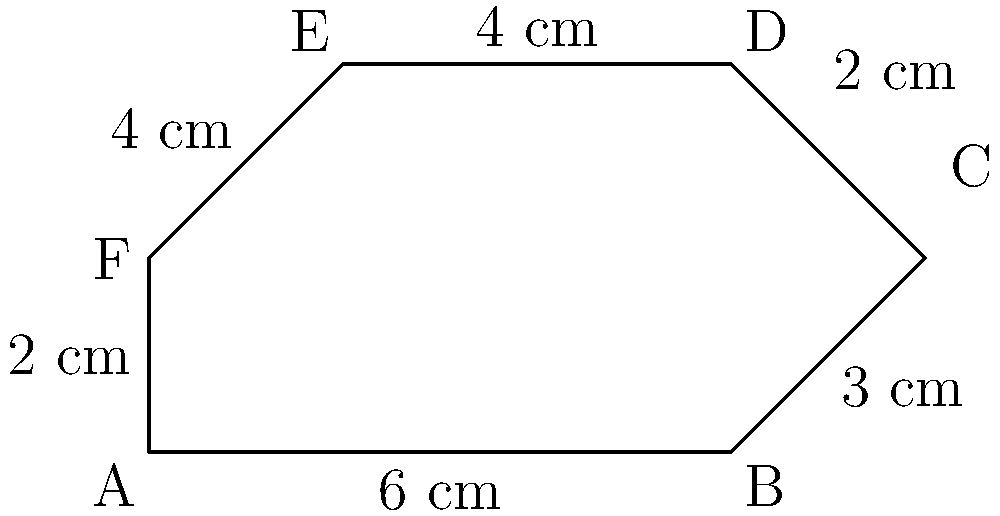You've designed a unique, irregular hexagon-shaped textile pattern for a local artisan. The measurements of each side are shown in the diagram. What is the perimeter of this textile pattern in centimeters? To find the perimeter of the irregular hexagon-shaped textile pattern, we need to sum up the lengths of all sides. Let's go through this step-by-step:

1. Identify the length of each side:
   - Side AB = 6 cm
   - Side BC = 3 cm
   - Side CD = 2 cm
   - Side DE = 4 cm
   - Side EF = 4 cm
   - Side FA = 2 cm

2. Add up all the side lengths:
   $$\text{Perimeter} = AB + BC + CD + DE + EF + FA$$
   $$\text{Perimeter} = 6 + 3 + 2 + 4 + 4 + 2$$
   $$\text{Perimeter} = 21 \text{ cm}$$

Therefore, the perimeter of the irregular hexagon-shaped textile pattern is 21 cm.
Answer: 21 cm 